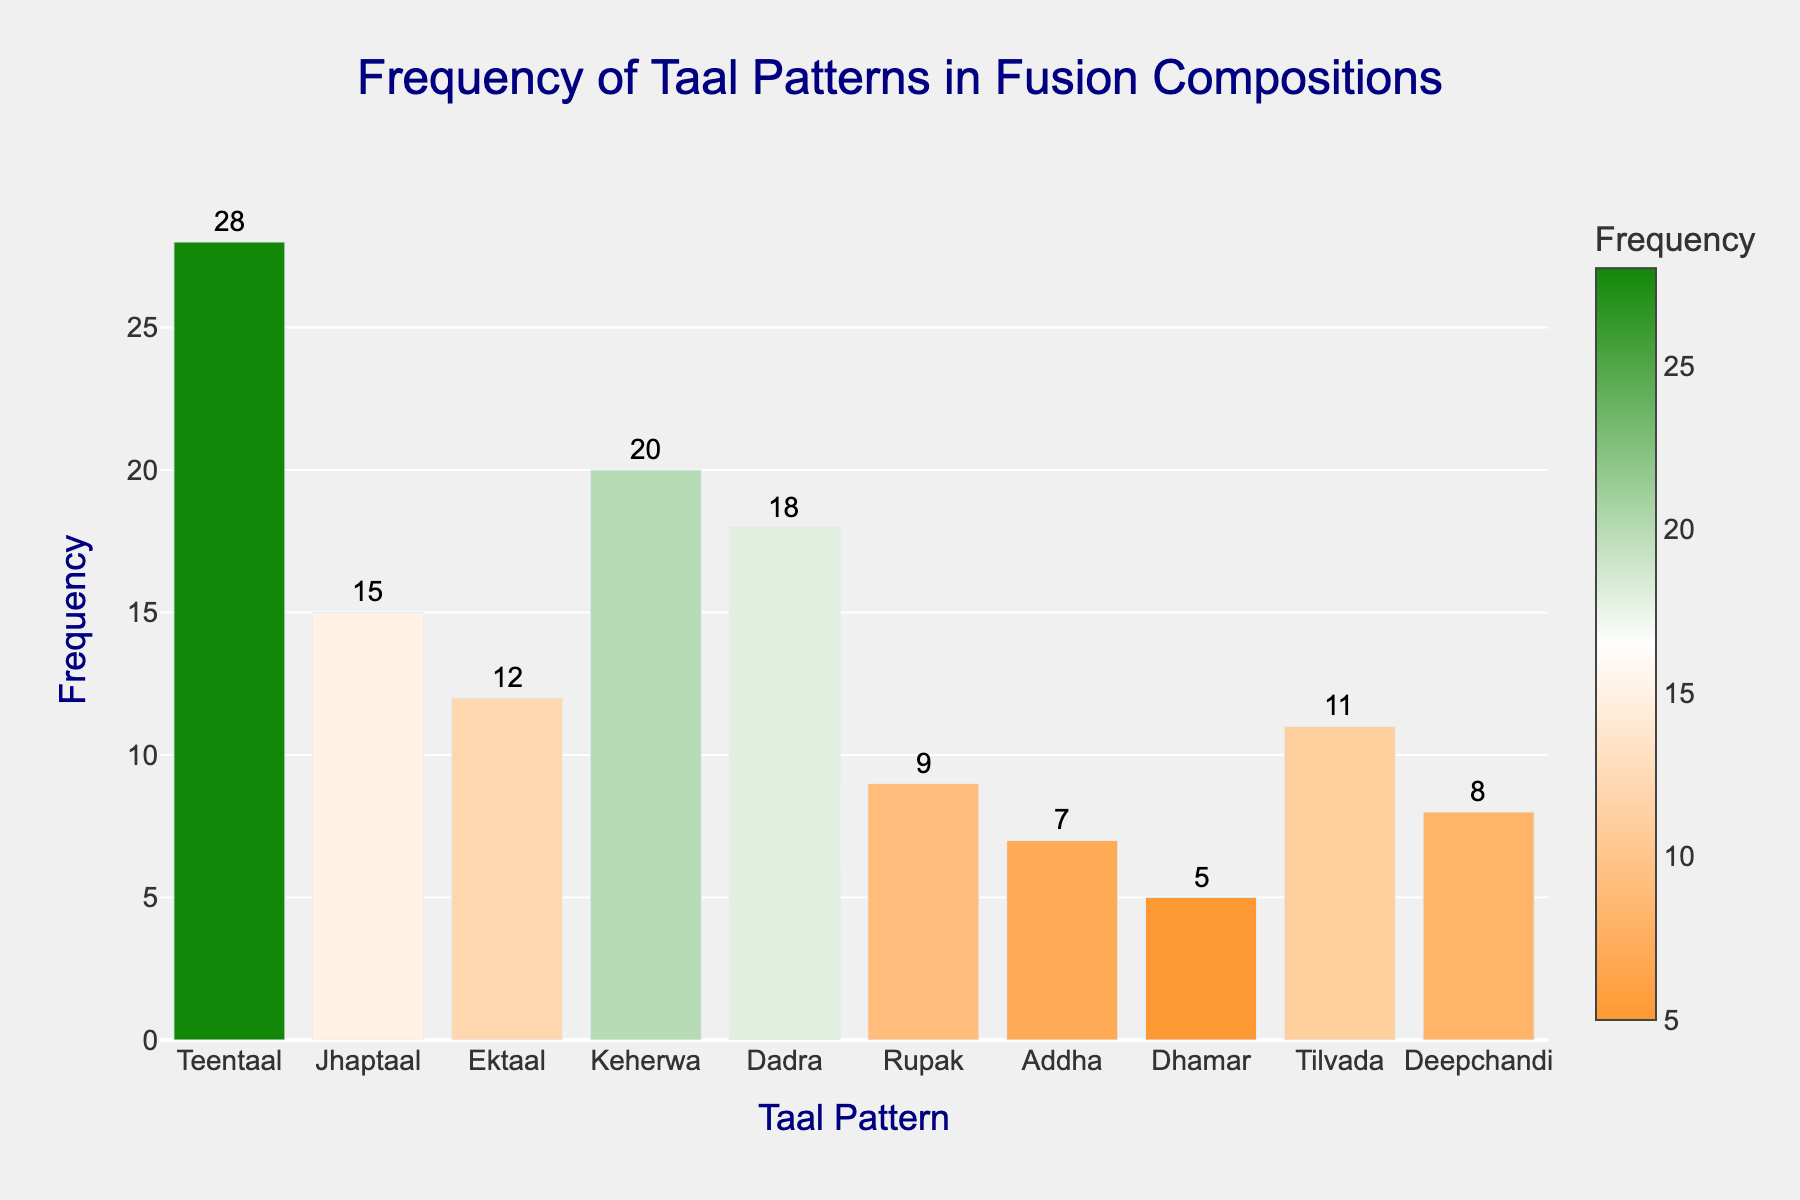What's the title of the histogram? The title is usually mentioned at the very top of a histogram. By reading the text located at the top center of the figure, you can see the title.
Answer: Frequency of Taal Patterns in Fusion Compositions Which taal pattern has the highest frequency? By observing the height of the bars in the histogram, the tallest bar represents the highest frequency. You can identify the corresponding taal pattern from the x-axis label.
Answer: Teentaal What is the frequency of Dhamar? The frequency of each taal pattern is indicated by the height of the bar above the corresponding x-axis label. Look at the bar labeled "Dhamar" and read the frequency.
Answer: 5 Which two taal patterns have a frequency greater than 15? Look for bars that extend above the 15 mark on the y-axis. Identify the corresponding taal patterns from the x-axis labels.
Answer: Teentaal and Keherwa Which taal pattern is least frequently used? Identify the shortest bar in the histogram, which represents the taal pattern with the smallest frequency.
Answer: Dhamar List all taal patterns that have a frequency less than 10. Check the y-axis values of each bar and identify those that are lower than 10.
Answer: Rupak, Addha, Dhamar, and Deepchandi What are the colors used in the frequency bars? The histogram utilizes a custom color scale. Identify the distinct colors visually represented along the bars.
Answer: Orange, white, and green 